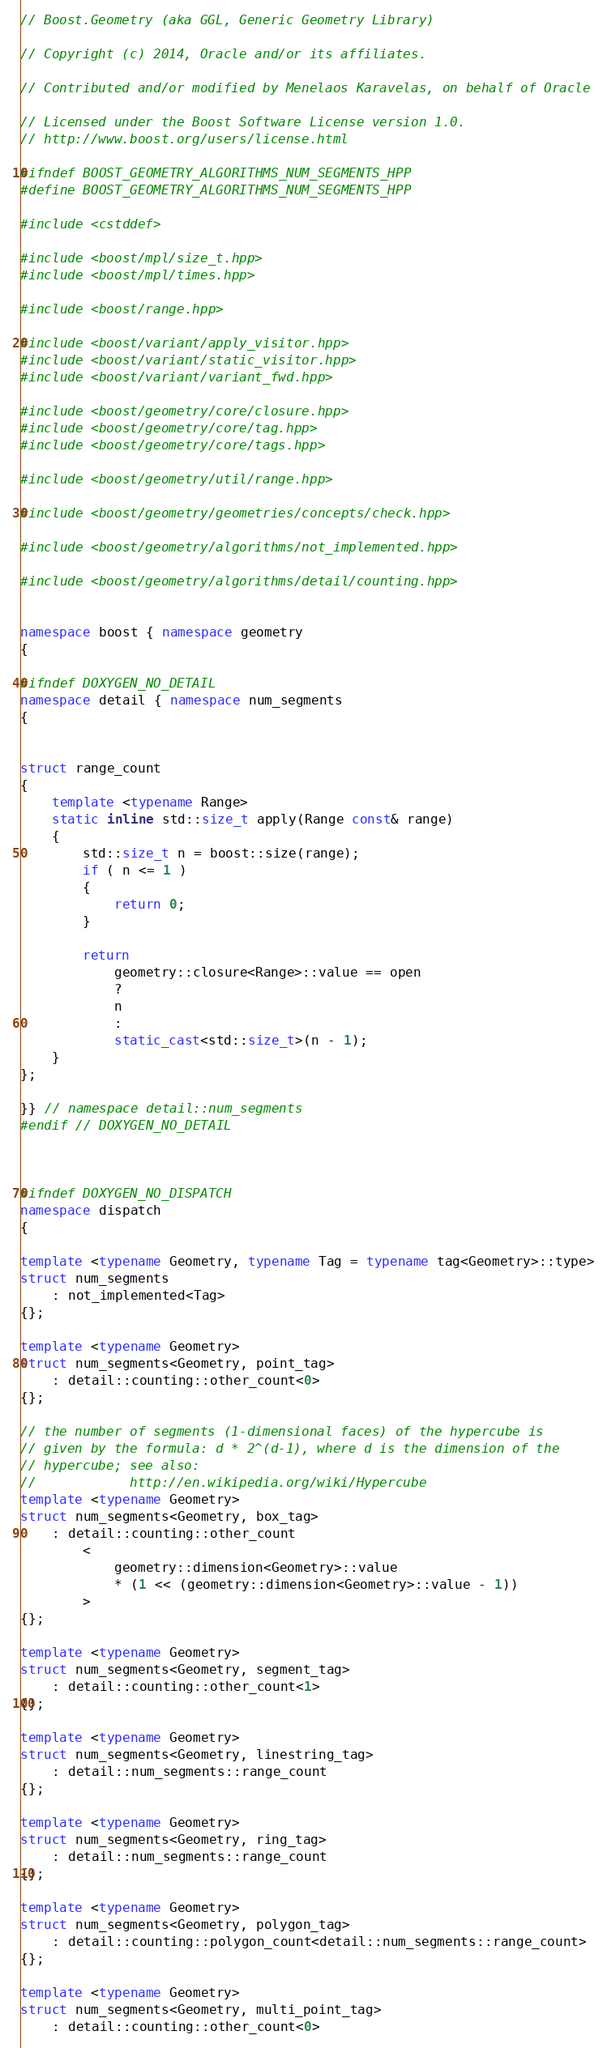<code> <loc_0><loc_0><loc_500><loc_500><_C++_>// Boost.Geometry (aka GGL, Generic Geometry Library)

// Copyright (c) 2014, Oracle and/or its affiliates.

// Contributed and/or modified by Menelaos Karavelas, on behalf of Oracle

// Licensed under the Boost Software License version 1.0.
// http://www.boost.org/users/license.html

#ifndef BOOST_GEOMETRY_ALGORITHMS_NUM_SEGMENTS_HPP
#define BOOST_GEOMETRY_ALGORITHMS_NUM_SEGMENTS_HPP

#include <cstddef>

#include <boost/mpl/size_t.hpp>
#include <boost/mpl/times.hpp>

#include <boost/range.hpp>

#include <boost/variant/apply_visitor.hpp>
#include <boost/variant/static_visitor.hpp>
#include <boost/variant/variant_fwd.hpp>

#include <boost/geometry/core/closure.hpp>
#include <boost/geometry/core/tag.hpp>
#include <boost/geometry/core/tags.hpp>

#include <boost/geometry/util/range.hpp>

#include <boost/geometry/geometries/concepts/check.hpp>

#include <boost/geometry/algorithms/not_implemented.hpp>

#include <boost/geometry/algorithms/detail/counting.hpp>


namespace boost { namespace geometry
{

#ifndef DOXYGEN_NO_DETAIL
namespace detail { namespace num_segments
{


struct range_count
{
    template <typename Range>
    static inline std::size_t apply(Range const& range)
    {
        std::size_t n = boost::size(range);
        if ( n <= 1 )
        {
            return 0;
        }

        return
            geometry::closure<Range>::value == open
            ?
            n
            :
            static_cast<std::size_t>(n - 1);
    }
};

}} // namespace detail::num_segments
#endif // DOXYGEN_NO_DETAIL



#ifndef DOXYGEN_NO_DISPATCH
namespace dispatch
{

template <typename Geometry, typename Tag = typename tag<Geometry>::type>
struct num_segments
    : not_implemented<Tag>
{};

template <typename Geometry>
struct num_segments<Geometry, point_tag>
    : detail::counting::other_count<0>
{};

// the number of segments (1-dimensional faces) of the hypercube is
// given by the formula: d * 2^(d-1), where d is the dimension of the
// hypercube; see also:
//            http://en.wikipedia.org/wiki/Hypercube
template <typename Geometry>
struct num_segments<Geometry, box_tag>
    : detail::counting::other_count
        <
            geometry::dimension<Geometry>::value
            * (1 << (geometry::dimension<Geometry>::value - 1))
        >
{};

template <typename Geometry>
struct num_segments<Geometry, segment_tag>
    : detail::counting::other_count<1>
{};

template <typename Geometry>
struct num_segments<Geometry, linestring_tag>
    : detail::num_segments::range_count
{};

template <typename Geometry>
struct num_segments<Geometry, ring_tag>
    : detail::num_segments::range_count
{};

template <typename Geometry>
struct num_segments<Geometry, polygon_tag>
    : detail::counting::polygon_count<detail::num_segments::range_count>
{};

template <typename Geometry>
struct num_segments<Geometry, multi_point_tag>
    : detail::counting::other_count<0></code> 